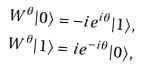<formula> <loc_0><loc_0><loc_500><loc_500>W ^ { \theta } | 0 \rangle = - i e ^ { i \theta } | 1 \rangle , \\ W ^ { \theta } | 1 \rangle = i e ^ { - i \theta } | 0 \rangle ,</formula> 